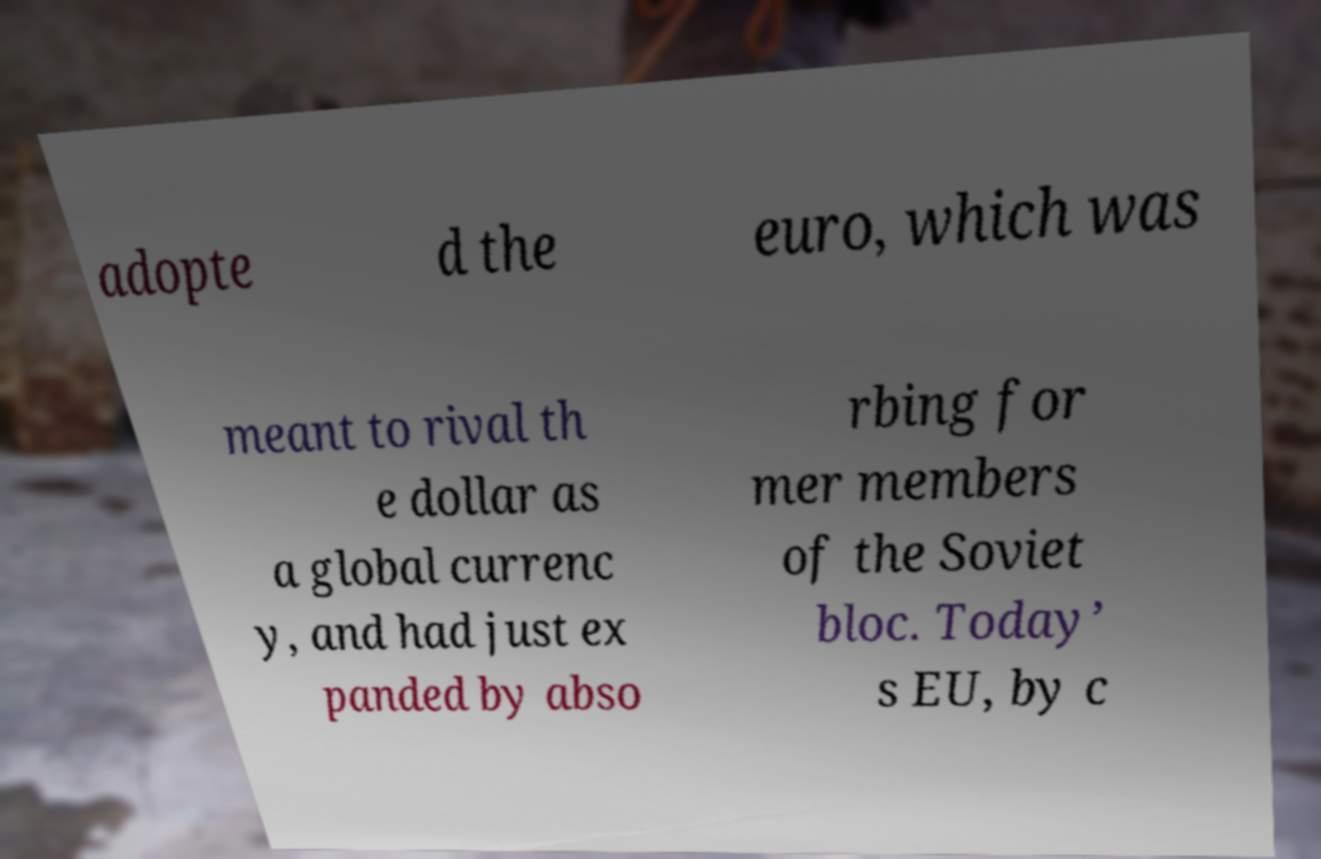Can you read and provide the text displayed in the image?This photo seems to have some interesting text. Can you extract and type it out for me? adopte d the euro, which was meant to rival th e dollar as a global currenc y, and had just ex panded by abso rbing for mer members of the Soviet bloc. Today’ s EU, by c 